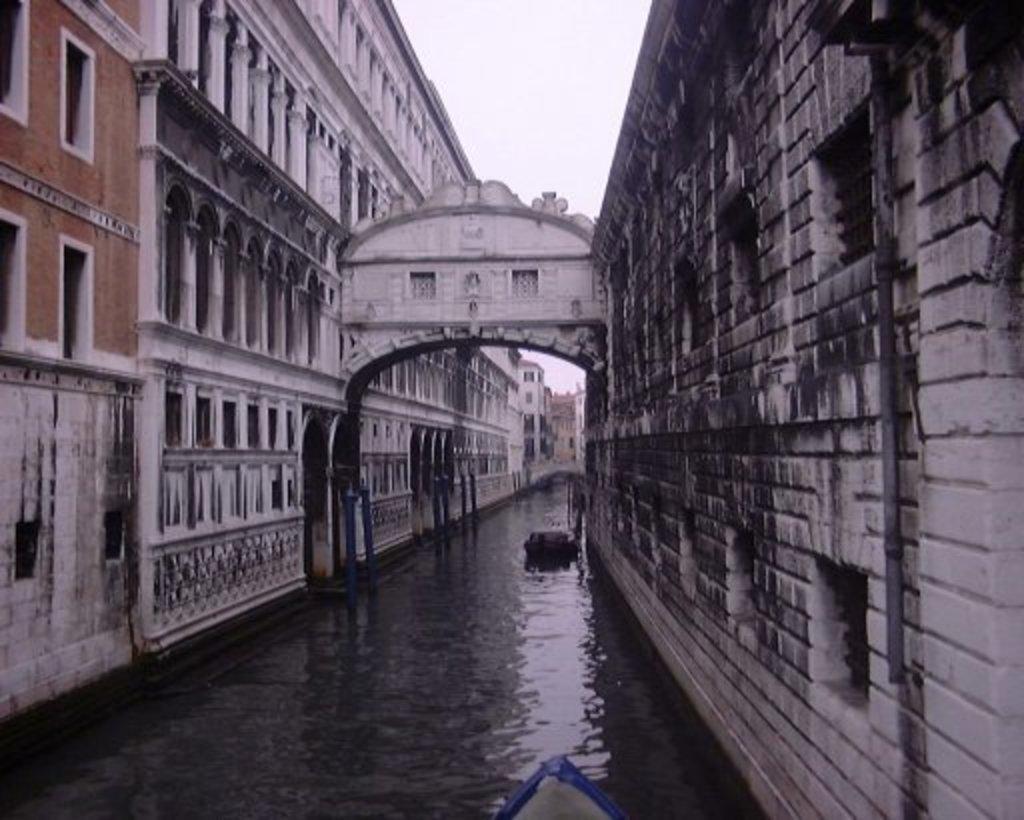How would you summarize this image in a sentence or two? In this image there is a canal, on either side of the canal there are buildings, in the background there is the sky. 